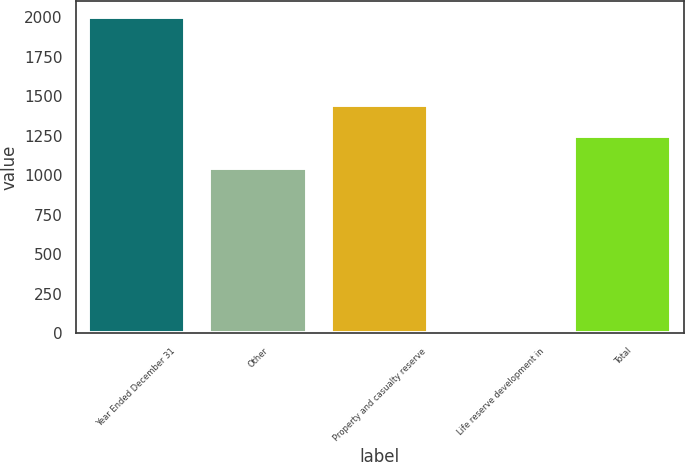<chart> <loc_0><loc_0><loc_500><loc_500><bar_chart><fcel>Year Ended December 31<fcel>Other<fcel>Property and casualty reserve<fcel>Life reserve development in<fcel>Total<nl><fcel>2005<fcel>1047<fcel>1446.6<fcel>7<fcel>1246.8<nl></chart> 